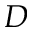<formula> <loc_0><loc_0><loc_500><loc_500>D</formula> 